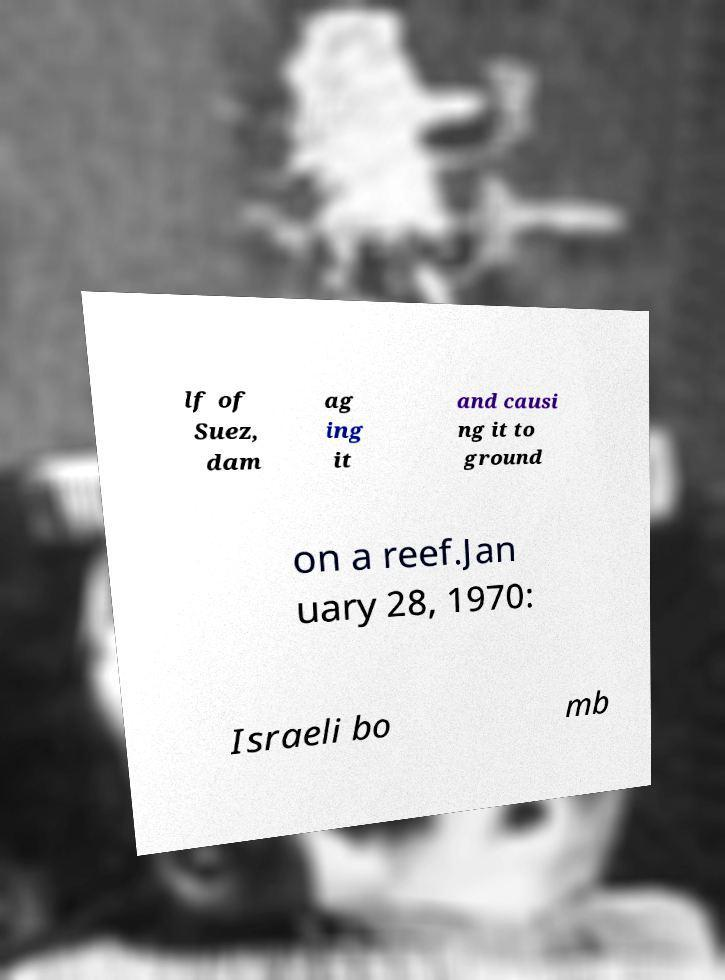Please identify and transcribe the text found in this image. lf of Suez, dam ag ing it and causi ng it to ground on a reef.Jan uary 28, 1970: Israeli bo mb 